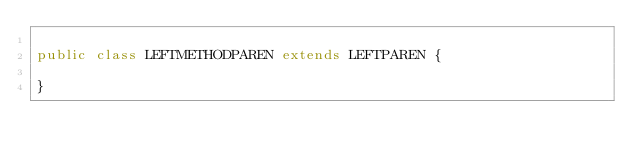Convert code to text. <code><loc_0><loc_0><loc_500><loc_500><_Java_>
public class LEFTMETHODPAREN extends LEFTPAREN {

}
</code> 